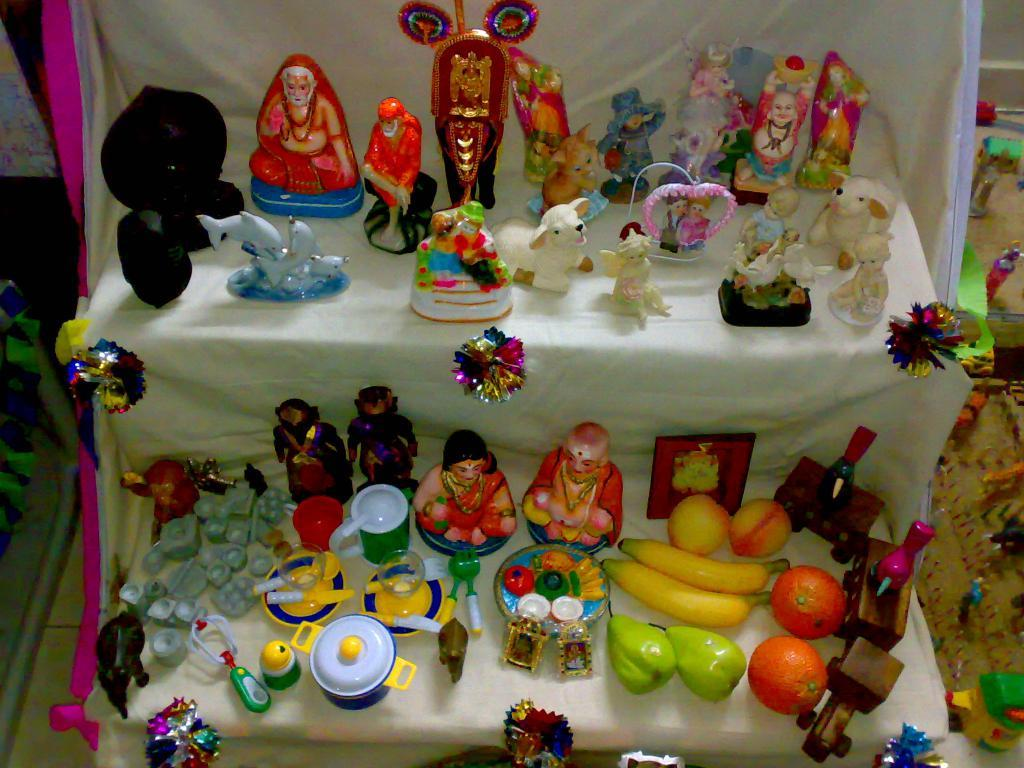What types of objects can be seen in the image? There are statues, dolls, and toys in the image. Where are the toys located in the image? Toys are visible on the right side of the image. What is present on the left side of the image? Objects are visible on the left side of the image. Are there any objects on a stand in the image? Yes, there are objects on a stand in the image. How many plants are visible in the image? There are no plants visible in the image. What type of chess piece can be seen in the image? There is no chess piece present in the image. 